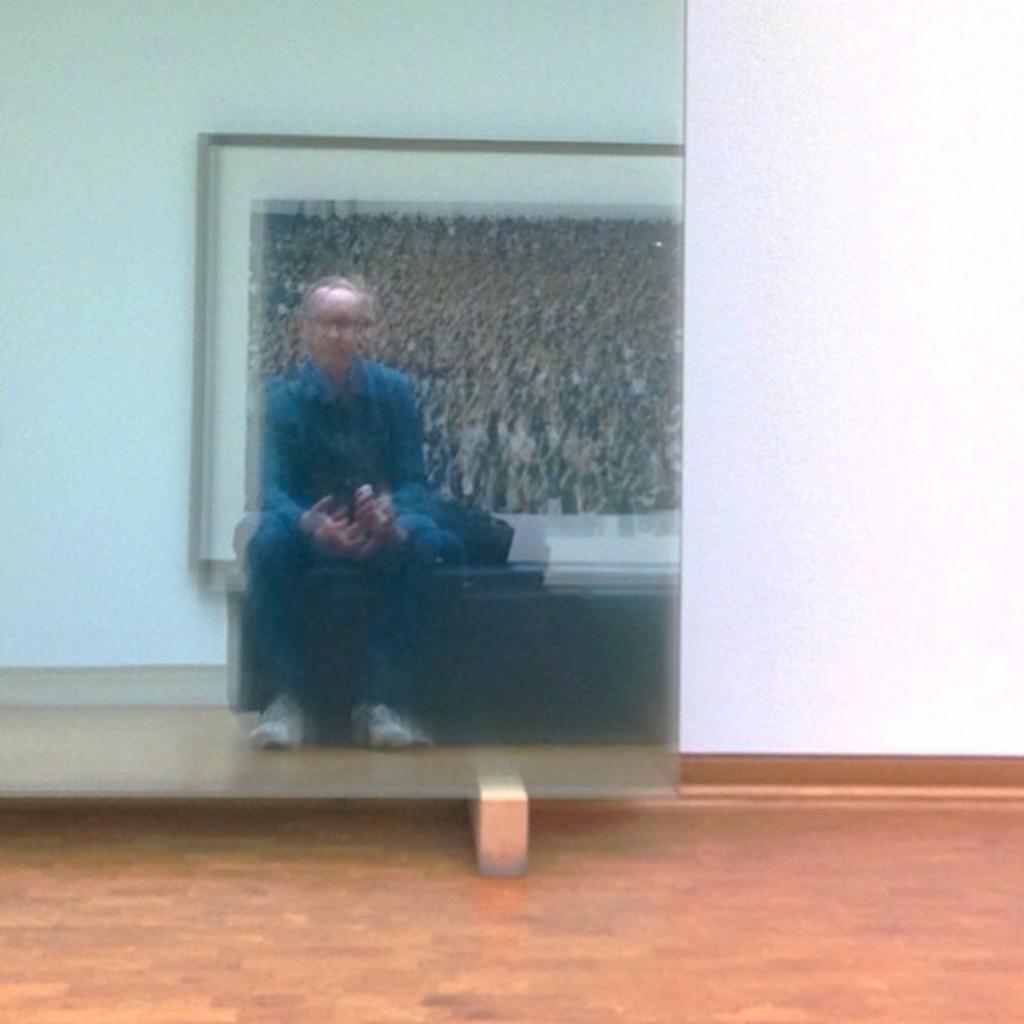What object is located on the left side of the image? There is a mirror on the left side of the image. What does the mirror reflect in the image? The mirror reflects a person in the image. What can be seen in the mirror's reflection besides the person? There is a photo frame visible in the mirror's reflection. What is visible in the background of the image? There is a wall in the background of the image. How many hoses are visible in the image? There are no hoses present in the image. What is the edge of the mirror like in the image? The edge of the mirror is not visible in the image, as only the mirror's reflection is shown. 